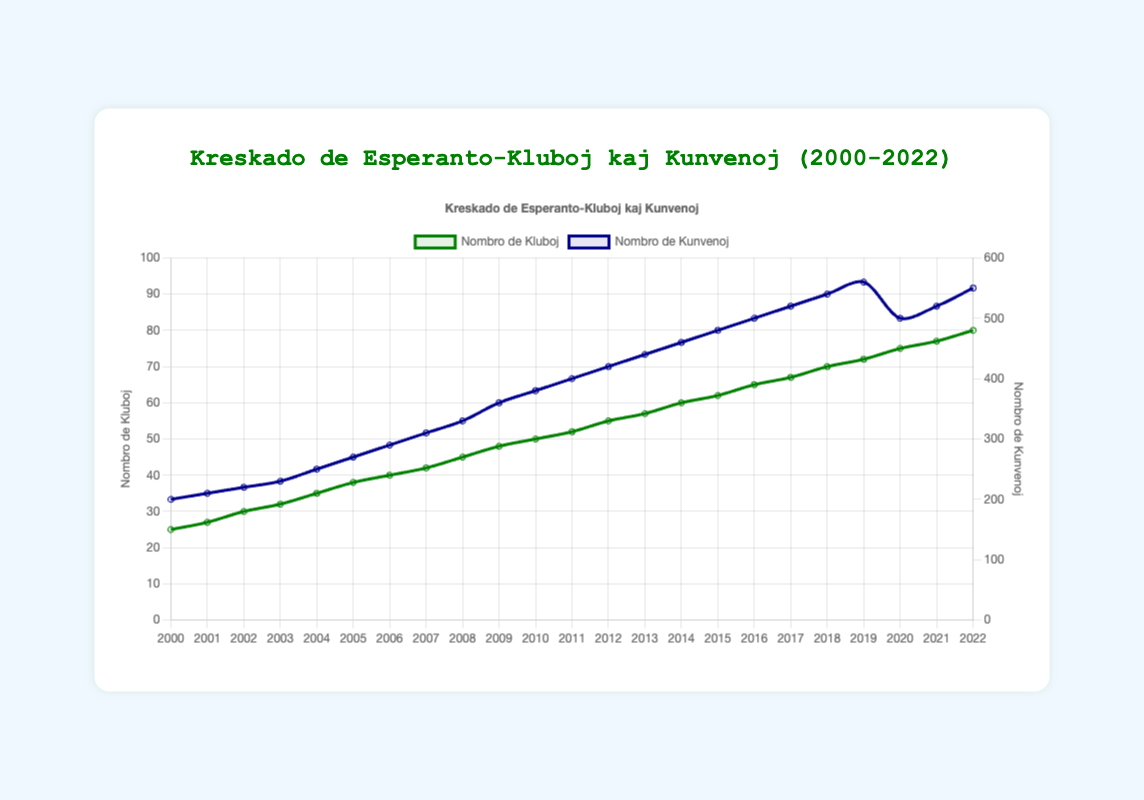Which year reported the highest number of clubs? From the figure, we can see that the number of clubs consistently increased each year, reaching its peak in 2022.
Answer: 2022 Compare the number of meetups in 2019 and 2020. Which year had more meetups and by how many? In 2019, there were 560 meetups, while in 2020, there were 500 meetups. Subtracting these values, we see that 2019 had 60 more meetups.
Answer: 2019, by 60 Between 2000 and 2022, what is the overall increase in the number of clubs? In 2000, the number of clubs was 25. By 2022, the number of clubs grew to 80. Subtracting the initial value from the final value, 80 - 25, we get an overall increase of 55 clubs.
Answer: 55 What is the average number of meetups from 2018 to 2020? The number of meetups for the years 2018, 2019, and 2020 are 540, 560, and 500 respectively. Adding these together gives 540 + 560 + 500 = 1600. Dividing by the number of years, we get 1600 / 3 ≈ 533.33.
Answer: 533.33 Did the frequency of meetups drop between any consecutive years, and if so, which years and by how many? Yes, the frequency of meetups dropped between the years 2019 and 2020 (from 560 to 500). The drop was by 560 - 500 = 60 meetups.
Answer: 2019-2020, by 60 In which year(s) did both the number of clubs and the number of meetups increase compared to the previous year? Every year from 2000 to 2022 shows an increase in both clubs and meetups compared to the previous year, except for 2020, which saw a decrease in meetups.
Answer: 2000-2019, 2021-2022 Compare the annual growth rate of clubs and meetups in 2020. Which one had a larger change? The growth rate of clubs from 2019 to 2020 was (75 - 72) = 3. The change in meetups from 2019 to 2020 was (500 - 560) = -60. Comparing the magnitudes, meetups experienced a larger change numerically.
Answer: Meetups What is the overall trend observed for the number of Esperanto clubs and meetups from 2000 to 2022? The overall trend for both the number of clubs and meetups shows an increase over the years, apart from a dip in meetups in 2020. The growth resumes post-2020.
Answer: Increasing, with a dip in 2020 Calculate the rate of increase in the number of clubs from 2005 to 2010. In 2005, there were 38 clubs, and by 2010, there were 50 clubs. The increase is 50 - 38 = 12 clubs. The rate of increase over 5 years is 12 / 5 = 2.4 clubs per year.
Answer: 2.4 clubs per year 